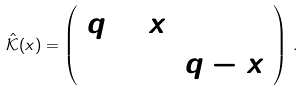<formula> <loc_0><loc_0><loc_500><loc_500>\hat { \mathcal { K } } ( x ) = \left ( \begin{array} { c c } q + x & 0 \\ 0 & q - x \end{array} \right ) \, .</formula> 